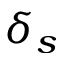Convert formula to latex. <formula><loc_0><loc_0><loc_500><loc_500>\delta _ { s }</formula> 